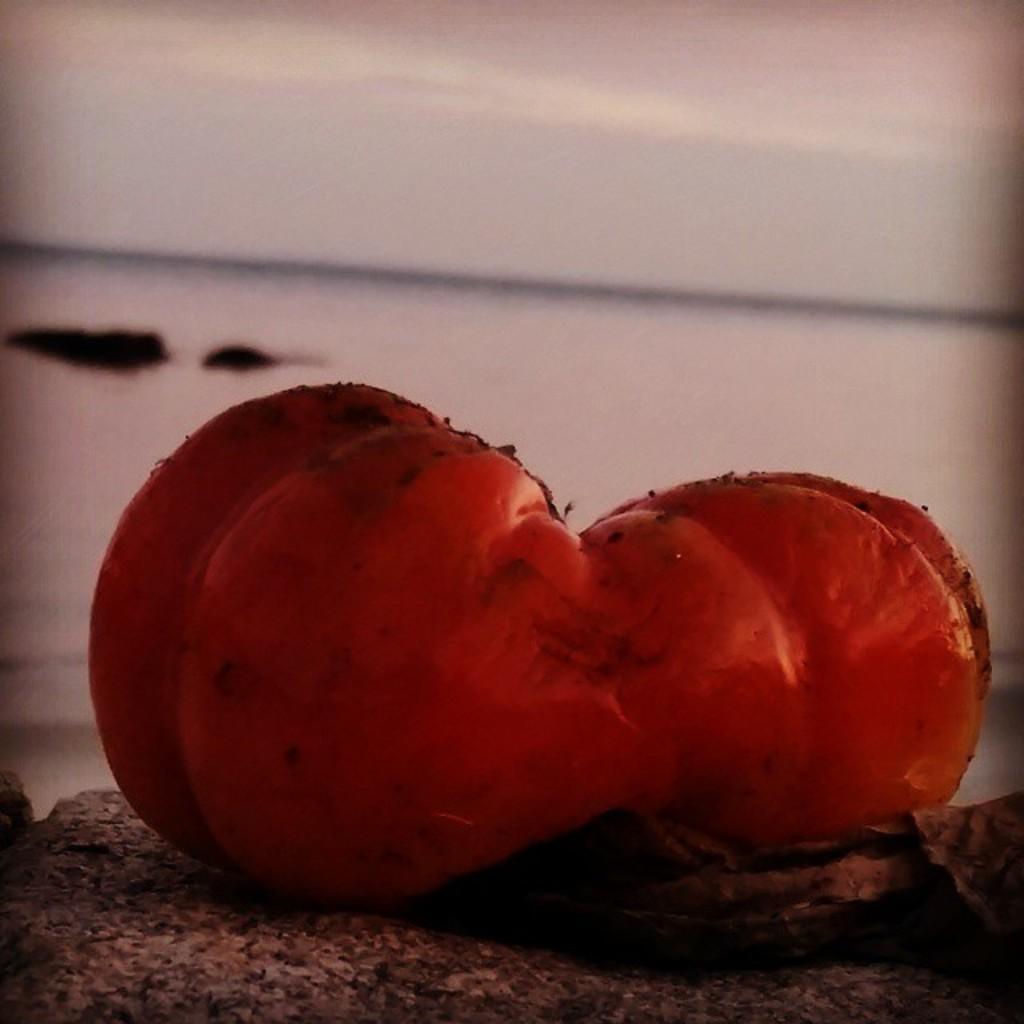Please provide a concise description of this image. In this image in the foreground there is a vegetable, at the bottom there is a rock and in the background there is a beach and at the top of the image there is sky. 